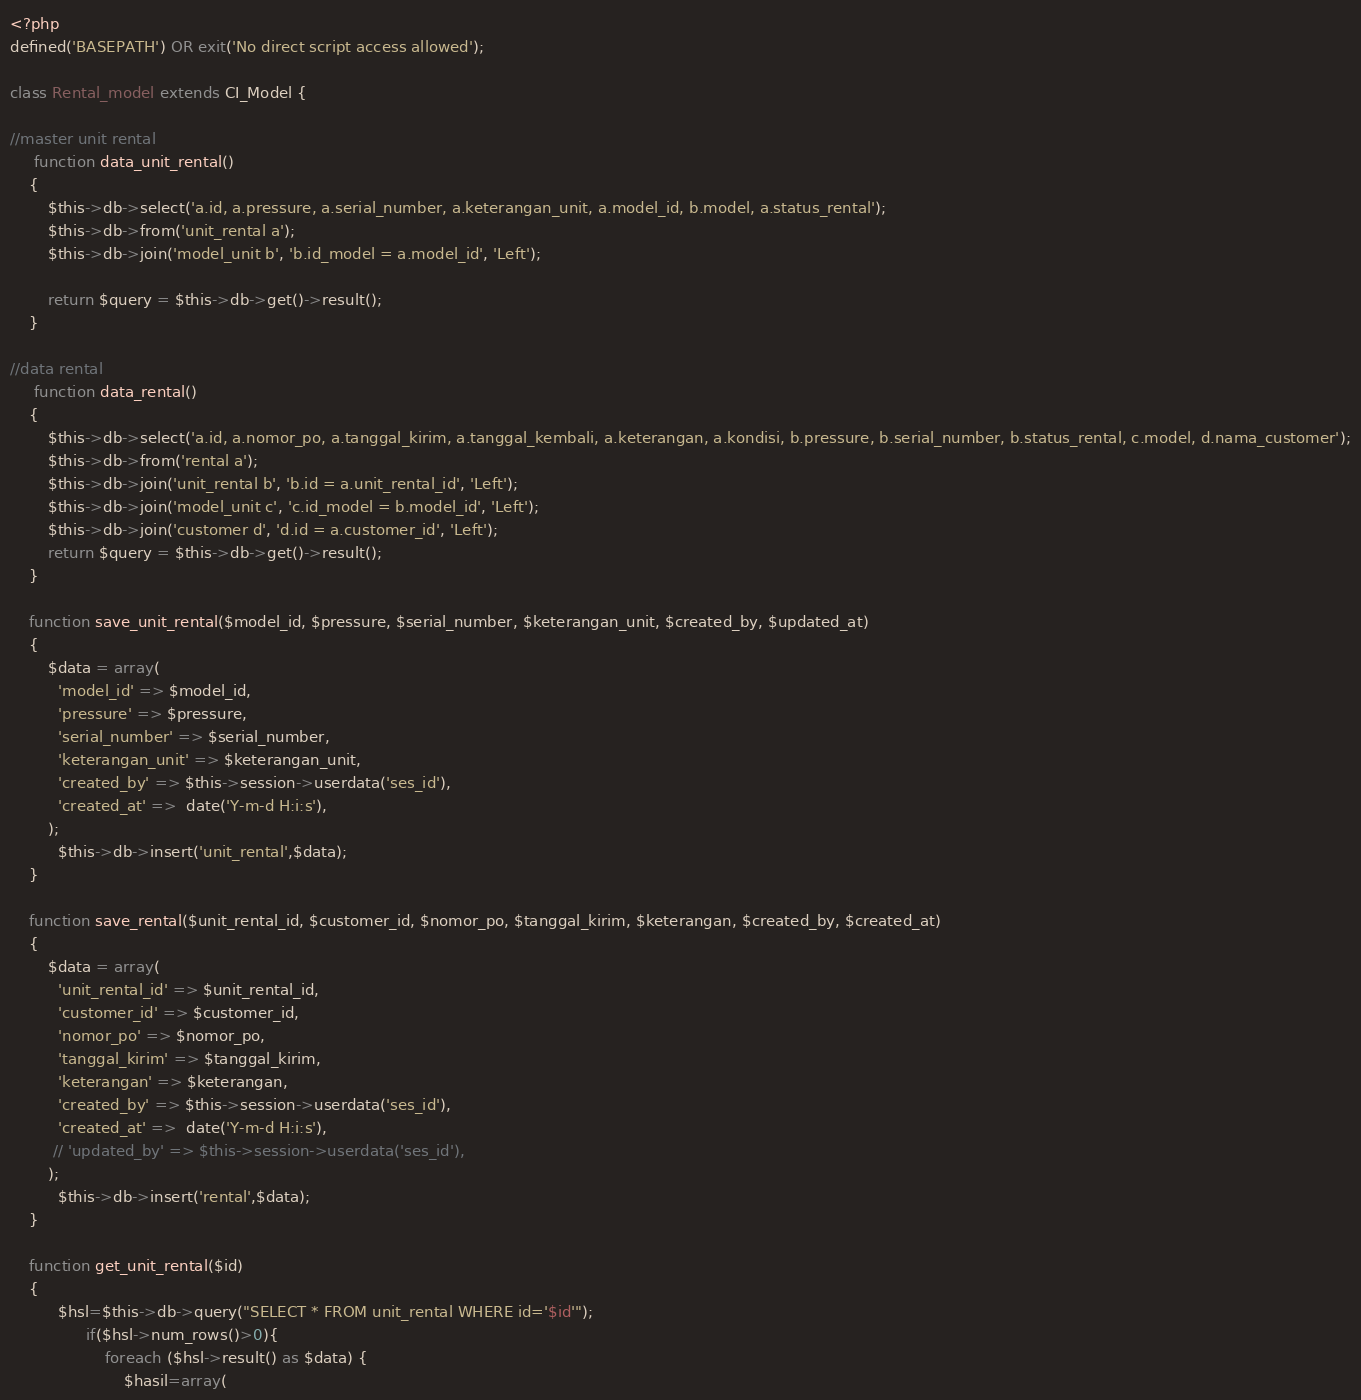<code> <loc_0><loc_0><loc_500><loc_500><_PHP_><?php
defined('BASEPATH') OR exit('No direct script access allowed');

class Rental_model extends CI_Model {

//master unit rental
	 function data_unit_rental()
	{
		$this->db->select('a.id, a.pressure, a.serial_number, a.keterangan_unit, a.model_id, b.model, a.status_rental');
		$this->db->from('unit_rental a');
		$this->db->join('model_unit b', 'b.id_model = a.model_id', 'Left');
		
		return $query = $this->db->get()->result();
	}

//data rental
	 function data_rental()
	{
		$this->db->select('a.id, a.nomor_po, a.tanggal_kirim, a.tanggal_kembali, a.keterangan, a.kondisi, b.pressure, b.serial_number, b.status_rental, c.model, d.nama_customer');
		$this->db->from('rental a');
		$this->db->join('unit_rental b', 'b.id = a.unit_rental_id', 'Left');
		$this->db->join('model_unit c', 'c.id_model = b.model_id', 'Left');		
		$this->db->join('customer d', 'd.id = a.customer_id', 'Left');
		return $query = $this->db->get()->result();
	}

	function save_unit_rental($model_id, $pressure, $serial_number, $keterangan_unit, $created_by, $updated_at)
	{
	    $data = array(      
	      'model_id' => $model_id,
	      'pressure' => $pressure,
	      'serial_number' => $serial_number,
	      'keterangan_unit' => $keterangan_unit,
	      'created_by' => $this->session->userdata('ses_id'),
	      'created_at' =>  date('Y-m-d H:i:s'),
	    );
	      $this->db->insert('unit_rental',$data);
	}

	function save_rental($unit_rental_id, $customer_id, $nomor_po, $tanggal_kirim, $keterangan, $created_by, $created_at)
	{
	    $data = array(      
	      'unit_rental_id' => $unit_rental_id,
	      'customer_id' => $customer_id,     
	      'nomor_po' => $nomor_po,
	      'tanggal_kirim' => $tanggal_kirim,
	      'keterangan' => $keterangan,
	      'created_by' => $this->session->userdata('ses_id'),
	      'created_at' =>  date('Y-m-d H:i:s'),
	     // 'updated_by' => $this->session->userdata('ses_id'),
	    );
	      $this->db->insert('rental',$data);
	}

	function get_unit_rental($id)
  	{
		  $hsl=$this->db->query("SELECT * FROM unit_rental WHERE id='$id'");
		        if($hsl->num_rows()>0){
		            foreach ($hsl->result() as $data) {
		                $hasil=array(</code> 